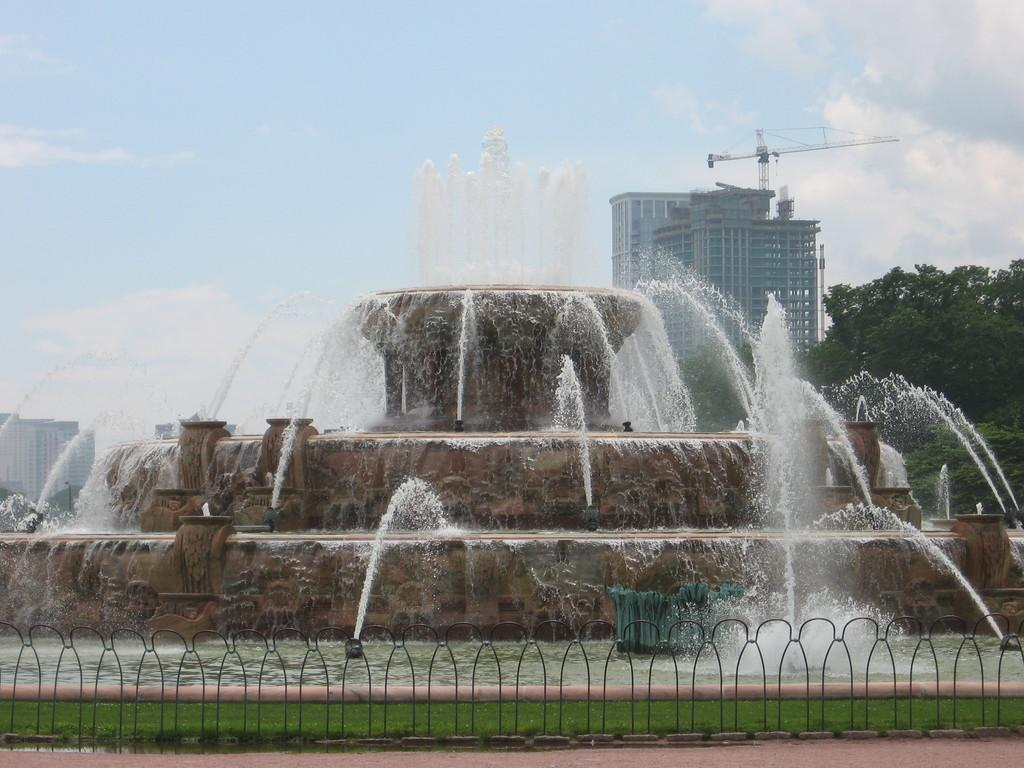What type of structure is in the image? There is a metal grill in the image. What can be seen in the background of the image? There is a fountain, trees, and a building in the background of the image. What is visible at the top of the image? The sky is visible at the top of the image. What type of offer is the rat holding with a hammer in the image? There is no rat or hammer present in the image. What kind of deal is being made with the hammer and offer in the image? There is no deal or offer involving a hammer in the image, as there are no such objects or actions depicted. 